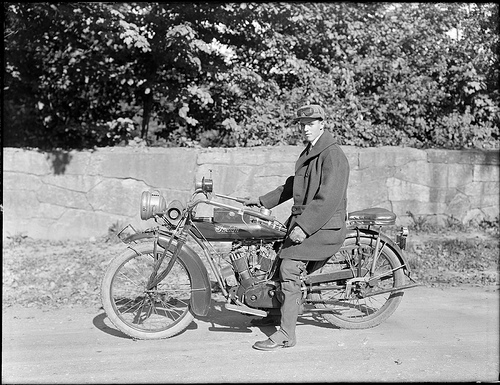<image>Where are the eyeglasses? There are no eyeglasses in sight. However, if present, they might be on top of the hat. Where are the eyeglasses? There are no eyeglasses in sight. 